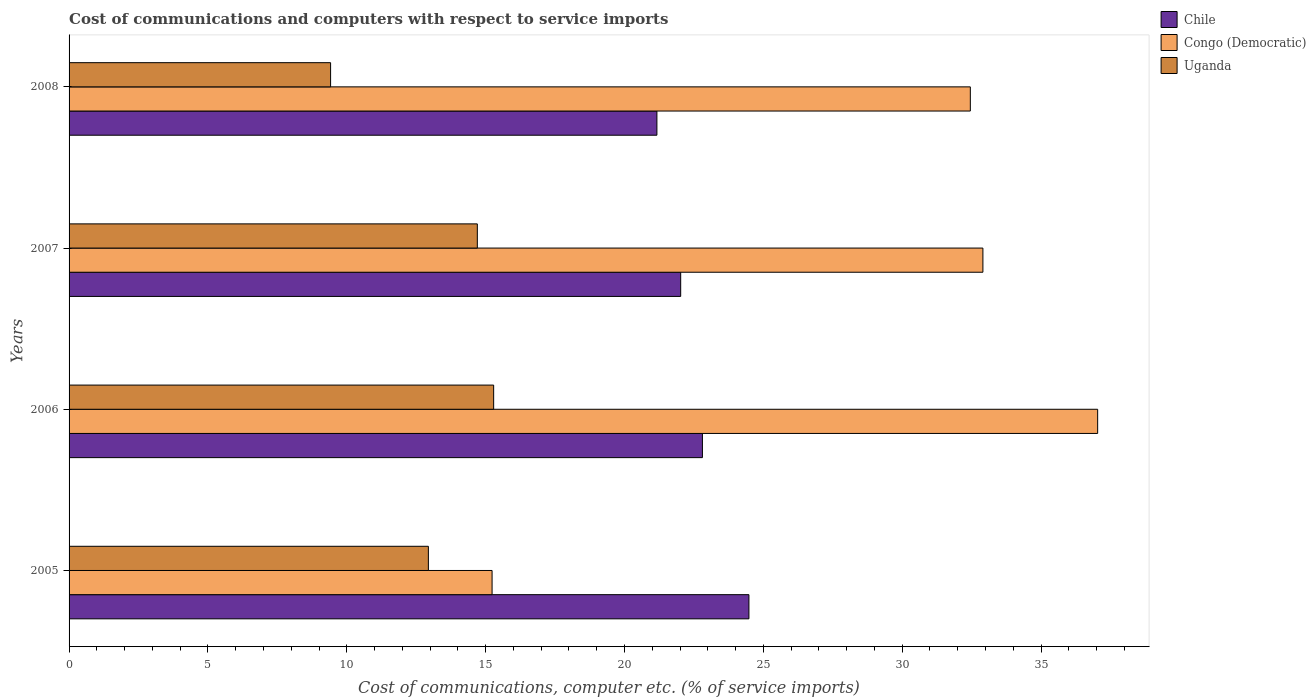How many different coloured bars are there?
Offer a very short reply. 3. How many bars are there on the 3rd tick from the top?
Offer a very short reply. 3. How many bars are there on the 4th tick from the bottom?
Offer a terse response. 3. In how many cases, is the number of bars for a given year not equal to the number of legend labels?
Give a very brief answer. 0. What is the cost of communications and computers in Uganda in 2006?
Your response must be concise. 15.29. Across all years, what is the maximum cost of communications and computers in Congo (Democratic)?
Your response must be concise. 37.04. Across all years, what is the minimum cost of communications and computers in Uganda?
Make the answer very short. 9.42. In which year was the cost of communications and computers in Chile minimum?
Make the answer very short. 2008. What is the total cost of communications and computers in Chile in the graph?
Provide a succinct answer. 90.48. What is the difference between the cost of communications and computers in Uganda in 2007 and that in 2008?
Offer a terse response. 5.28. What is the difference between the cost of communications and computers in Chile in 2006 and the cost of communications and computers in Uganda in 2005?
Provide a succinct answer. 9.87. What is the average cost of communications and computers in Chile per year?
Give a very brief answer. 22.62. In the year 2005, what is the difference between the cost of communications and computers in Chile and cost of communications and computers in Congo (Democratic)?
Offer a very short reply. 9.25. What is the ratio of the cost of communications and computers in Congo (Democratic) in 2006 to that in 2007?
Your answer should be compact. 1.13. Is the difference between the cost of communications and computers in Chile in 2005 and 2006 greater than the difference between the cost of communications and computers in Congo (Democratic) in 2005 and 2006?
Offer a very short reply. Yes. What is the difference between the highest and the second highest cost of communications and computers in Chile?
Make the answer very short. 1.67. What is the difference between the highest and the lowest cost of communications and computers in Congo (Democratic)?
Ensure brevity in your answer.  21.81. What does the 1st bar from the top in 2007 represents?
Your answer should be very brief. Uganda. What does the 2nd bar from the bottom in 2008 represents?
Offer a terse response. Congo (Democratic). Is it the case that in every year, the sum of the cost of communications and computers in Congo (Democratic) and cost of communications and computers in Uganda is greater than the cost of communications and computers in Chile?
Your answer should be very brief. Yes. How many bars are there?
Your answer should be compact. 12. Are all the bars in the graph horizontal?
Provide a short and direct response. Yes. How many years are there in the graph?
Provide a succinct answer. 4. Are the values on the major ticks of X-axis written in scientific E-notation?
Provide a short and direct response. No. Does the graph contain any zero values?
Offer a very short reply. No. Does the graph contain grids?
Provide a short and direct response. No. How many legend labels are there?
Your answer should be very brief. 3. What is the title of the graph?
Your answer should be compact. Cost of communications and computers with respect to service imports. What is the label or title of the X-axis?
Your response must be concise. Cost of communications, computer etc. (% of service imports). What is the label or title of the Y-axis?
Provide a short and direct response. Years. What is the Cost of communications, computer etc. (% of service imports) of Chile in 2005?
Offer a very short reply. 24.48. What is the Cost of communications, computer etc. (% of service imports) of Congo (Democratic) in 2005?
Offer a terse response. 15.23. What is the Cost of communications, computer etc. (% of service imports) of Uganda in 2005?
Ensure brevity in your answer.  12.94. What is the Cost of communications, computer etc. (% of service imports) in Chile in 2006?
Ensure brevity in your answer.  22.81. What is the Cost of communications, computer etc. (% of service imports) of Congo (Democratic) in 2006?
Keep it short and to the point. 37.04. What is the Cost of communications, computer etc. (% of service imports) in Uganda in 2006?
Give a very brief answer. 15.29. What is the Cost of communications, computer etc. (% of service imports) in Chile in 2007?
Make the answer very short. 22.02. What is the Cost of communications, computer etc. (% of service imports) of Congo (Democratic) in 2007?
Offer a terse response. 32.91. What is the Cost of communications, computer etc. (% of service imports) in Uganda in 2007?
Provide a short and direct response. 14.7. What is the Cost of communications, computer etc. (% of service imports) of Chile in 2008?
Your answer should be very brief. 21.17. What is the Cost of communications, computer etc. (% of service imports) of Congo (Democratic) in 2008?
Keep it short and to the point. 32.45. What is the Cost of communications, computer etc. (% of service imports) in Uganda in 2008?
Your answer should be compact. 9.42. Across all years, what is the maximum Cost of communications, computer etc. (% of service imports) of Chile?
Make the answer very short. 24.48. Across all years, what is the maximum Cost of communications, computer etc. (% of service imports) in Congo (Democratic)?
Make the answer very short. 37.04. Across all years, what is the maximum Cost of communications, computer etc. (% of service imports) of Uganda?
Your answer should be compact. 15.29. Across all years, what is the minimum Cost of communications, computer etc. (% of service imports) in Chile?
Give a very brief answer. 21.17. Across all years, what is the minimum Cost of communications, computer etc. (% of service imports) of Congo (Democratic)?
Keep it short and to the point. 15.23. Across all years, what is the minimum Cost of communications, computer etc. (% of service imports) in Uganda?
Ensure brevity in your answer.  9.42. What is the total Cost of communications, computer etc. (% of service imports) in Chile in the graph?
Provide a short and direct response. 90.48. What is the total Cost of communications, computer etc. (% of service imports) in Congo (Democratic) in the graph?
Offer a terse response. 117.63. What is the total Cost of communications, computer etc. (% of service imports) in Uganda in the graph?
Keep it short and to the point. 52.35. What is the difference between the Cost of communications, computer etc. (% of service imports) of Chile in 2005 and that in 2006?
Make the answer very short. 1.67. What is the difference between the Cost of communications, computer etc. (% of service imports) in Congo (Democratic) in 2005 and that in 2006?
Keep it short and to the point. -21.81. What is the difference between the Cost of communications, computer etc. (% of service imports) in Uganda in 2005 and that in 2006?
Your answer should be compact. -2.35. What is the difference between the Cost of communications, computer etc. (% of service imports) in Chile in 2005 and that in 2007?
Provide a succinct answer. 2.46. What is the difference between the Cost of communications, computer etc. (% of service imports) in Congo (Democratic) in 2005 and that in 2007?
Your answer should be very brief. -17.67. What is the difference between the Cost of communications, computer etc. (% of service imports) in Uganda in 2005 and that in 2007?
Offer a terse response. -1.76. What is the difference between the Cost of communications, computer etc. (% of service imports) of Chile in 2005 and that in 2008?
Your answer should be compact. 3.31. What is the difference between the Cost of communications, computer etc. (% of service imports) in Congo (Democratic) in 2005 and that in 2008?
Give a very brief answer. -17.22. What is the difference between the Cost of communications, computer etc. (% of service imports) of Uganda in 2005 and that in 2008?
Your answer should be compact. 3.52. What is the difference between the Cost of communications, computer etc. (% of service imports) in Chile in 2006 and that in 2007?
Ensure brevity in your answer.  0.78. What is the difference between the Cost of communications, computer etc. (% of service imports) in Congo (Democratic) in 2006 and that in 2007?
Offer a terse response. 4.13. What is the difference between the Cost of communications, computer etc. (% of service imports) of Uganda in 2006 and that in 2007?
Offer a very short reply. 0.59. What is the difference between the Cost of communications, computer etc. (% of service imports) in Chile in 2006 and that in 2008?
Provide a succinct answer. 1.64. What is the difference between the Cost of communications, computer etc. (% of service imports) in Congo (Democratic) in 2006 and that in 2008?
Provide a short and direct response. 4.59. What is the difference between the Cost of communications, computer etc. (% of service imports) in Uganda in 2006 and that in 2008?
Provide a short and direct response. 5.87. What is the difference between the Cost of communications, computer etc. (% of service imports) of Chile in 2007 and that in 2008?
Offer a very short reply. 0.86. What is the difference between the Cost of communications, computer etc. (% of service imports) in Congo (Democratic) in 2007 and that in 2008?
Provide a succinct answer. 0.45. What is the difference between the Cost of communications, computer etc. (% of service imports) in Uganda in 2007 and that in 2008?
Give a very brief answer. 5.28. What is the difference between the Cost of communications, computer etc. (% of service imports) of Chile in 2005 and the Cost of communications, computer etc. (% of service imports) of Congo (Democratic) in 2006?
Your answer should be very brief. -12.56. What is the difference between the Cost of communications, computer etc. (% of service imports) in Chile in 2005 and the Cost of communications, computer etc. (% of service imports) in Uganda in 2006?
Offer a very short reply. 9.19. What is the difference between the Cost of communications, computer etc. (% of service imports) in Congo (Democratic) in 2005 and the Cost of communications, computer etc. (% of service imports) in Uganda in 2006?
Offer a terse response. -0.06. What is the difference between the Cost of communications, computer etc. (% of service imports) of Chile in 2005 and the Cost of communications, computer etc. (% of service imports) of Congo (Democratic) in 2007?
Provide a short and direct response. -8.43. What is the difference between the Cost of communications, computer etc. (% of service imports) in Chile in 2005 and the Cost of communications, computer etc. (% of service imports) in Uganda in 2007?
Offer a terse response. 9.78. What is the difference between the Cost of communications, computer etc. (% of service imports) in Congo (Democratic) in 2005 and the Cost of communications, computer etc. (% of service imports) in Uganda in 2007?
Give a very brief answer. 0.53. What is the difference between the Cost of communications, computer etc. (% of service imports) of Chile in 2005 and the Cost of communications, computer etc. (% of service imports) of Congo (Democratic) in 2008?
Your answer should be compact. -7.97. What is the difference between the Cost of communications, computer etc. (% of service imports) in Chile in 2005 and the Cost of communications, computer etc. (% of service imports) in Uganda in 2008?
Provide a short and direct response. 15.06. What is the difference between the Cost of communications, computer etc. (% of service imports) in Congo (Democratic) in 2005 and the Cost of communications, computer etc. (% of service imports) in Uganda in 2008?
Ensure brevity in your answer.  5.82. What is the difference between the Cost of communications, computer etc. (% of service imports) of Chile in 2006 and the Cost of communications, computer etc. (% of service imports) of Congo (Democratic) in 2007?
Make the answer very short. -10.1. What is the difference between the Cost of communications, computer etc. (% of service imports) of Chile in 2006 and the Cost of communications, computer etc. (% of service imports) of Uganda in 2007?
Provide a succinct answer. 8.11. What is the difference between the Cost of communications, computer etc. (% of service imports) of Congo (Democratic) in 2006 and the Cost of communications, computer etc. (% of service imports) of Uganda in 2007?
Make the answer very short. 22.34. What is the difference between the Cost of communications, computer etc. (% of service imports) in Chile in 2006 and the Cost of communications, computer etc. (% of service imports) in Congo (Democratic) in 2008?
Your answer should be compact. -9.65. What is the difference between the Cost of communications, computer etc. (% of service imports) in Chile in 2006 and the Cost of communications, computer etc. (% of service imports) in Uganda in 2008?
Your answer should be very brief. 13.39. What is the difference between the Cost of communications, computer etc. (% of service imports) in Congo (Democratic) in 2006 and the Cost of communications, computer etc. (% of service imports) in Uganda in 2008?
Your response must be concise. 27.62. What is the difference between the Cost of communications, computer etc. (% of service imports) in Chile in 2007 and the Cost of communications, computer etc. (% of service imports) in Congo (Democratic) in 2008?
Offer a terse response. -10.43. What is the difference between the Cost of communications, computer etc. (% of service imports) in Chile in 2007 and the Cost of communications, computer etc. (% of service imports) in Uganda in 2008?
Offer a very short reply. 12.61. What is the difference between the Cost of communications, computer etc. (% of service imports) in Congo (Democratic) in 2007 and the Cost of communications, computer etc. (% of service imports) in Uganda in 2008?
Give a very brief answer. 23.49. What is the average Cost of communications, computer etc. (% of service imports) in Chile per year?
Provide a short and direct response. 22.62. What is the average Cost of communications, computer etc. (% of service imports) in Congo (Democratic) per year?
Your answer should be very brief. 29.41. What is the average Cost of communications, computer etc. (% of service imports) in Uganda per year?
Give a very brief answer. 13.09. In the year 2005, what is the difference between the Cost of communications, computer etc. (% of service imports) in Chile and Cost of communications, computer etc. (% of service imports) in Congo (Democratic)?
Ensure brevity in your answer.  9.25. In the year 2005, what is the difference between the Cost of communications, computer etc. (% of service imports) of Chile and Cost of communications, computer etc. (% of service imports) of Uganda?
Keep it short and to the point. 11.54. In the year 2005, what is the difference between the Cost of communications, computer etc. (% of service imports) in Congo (Democratic) and Cost of communications, computer etc. (% of service imports) in Uganda?
Your response must be concise. 2.29. In the year 2006, what is the difference between the Cost of communications, computer etc. (% of service imports) in Chile and Cost of communications, computer etc. (% of service imports) in Congo (Democratic)?
Your answer should be very brief. -14.23. In the year 2006, what is the difference between the Cost of communications, computer etc. (% of service imports) in Chile and Cost of communications, computer etc. (% of service imports) in Uganda?
Give a very brief answer. 7.52. In the year 2006, what is the difference between the Cost of communications, computer etc. (% of service imports) in Congo (Democratic) and Cost of communications, computer etc. (% of service imports) in Uganda?
Offer a terse response. 21.75. In the year 2007, what is the difference between the Cost of communications, computer etc. (% of service imports) of Chile and Cost of communications, computer etc. (% of service imports) of Congo (Democratic)?
Your answer should be compact. -10.88. In the year 2007, what is the difference between the Cost of communications, computer etc. (% of service imports) in Chile and Cost of communications, computer etc. (% of service imports) in Uganda?
Ensure brevity in your answer.  7.32. In the year 2007, what is the difference between the Cost of communications, computer etc. (% of service imports) in Congo (Democratic) and Cost of communications, computer etc. (% of service imports) in Uganda?
Your response must be concise. 18.21. In the year 2008, what is the difference between the Cost of communications, computer etc. (% of service imports) of Chile and Cost of communications, computer etc. (% of service imports) of Congo (Democratic)?
Offer a very short reply. -11.29. In the year 2008, what is the difference between the Cost of communications, computer etc. (% of service imports) of Chile and Cost of communications, computer etc. (% of service imports) of Uganda?
Your answer should be compact. 11.75. In the year 2008, what is the difference between the Cost of communications, computer etc. (% of service imports) in Congo (Democratic) and Cost of communications, computer etc. (% of service imports) in Uganda?
Your response must be concise. 23.04. What is the ratio of the Cost of communications, computer etc. (% of service imports) of Chile in 2005 to that in 2006?
Offer a terse response. 1.07. What is the ratio of the Cost of communications, computer etc. (% of service imports) of Congo (Democratic) in 2005 to that in 2006?
Make the answer very short. 0.41. What is the ratio of the Cost of communications, computer etc. (% of service imports) of Uganda in 2005 to that in 2006?
Give a very brief answer. 0.85. What is the ratio of the Cost of communications, computer etc. (% of service imports) of Chile in 2005 to that in 2007?
Give a very brief answer. 1.11. What is the ratio of the Cost of communications, computer etc. (% of service imports) in Congo (Democratic) in 2005 to that in 2007?
Give a very brief answer. 0.46. What is the ratio of the Cost of communications, computer etc. (% of service imports) of Uganda in 2005 to that in 2007?
Make the answer very short. 0.88. What is the ratio of the Cost of communications, computer etc. (% of service imports) of Chile in 2005 to that in 2008?
Give a very brief answer. 1.16. What is the ratio of the Cost of communications, computer etc. (% of service imports) of Congo (Democratic) in 2005 to that in 2008?
Ensure brevity in your answer.  0.47. What is the ratio of the Cost of communications, computer etc. (% of service imports) of Uganda in 2005 to that in 2008?
Keep it short and to the point. 1.37. What is the ratio of the Cost of communications, computer etc. (% of service imports) in Chile in 2006 to that in 2007?
Offer a terse response. 1.04. What is the ratio of the Cost of communications, computer etc. (% of service imports) of Congo (Democratic) in 2006 to that in 2007?
Your answer should be very brief. 1.13. What is the ratio of the Cost of communications, computer etc. (% of service imports) of Chile in 2006 to that in 2008?
Provide a succinct answer. 1.08. What is the ratio of the Cost of communications, computer etc. (% of service imports) in Congo (Democratic) in 2006 to that in 2008?
Make the answer very short. 1.14. What is the ratio of the Cost of communications, computer etc. (% of service imports) in Uganda in 2006 to that in 2008?
Ensure brevity in your answer.  1.62. What is the ratio of the Cost of communications, computer etc. (% of service imports) of Chile in 2007 to that in 2008?
Offer a very short reply. 1.04. What is the ratio of the Cost of communications, computer etc. (% of service imports) of Uganda in 2007 to that in 2008?
Your answer should be compact. 1.56. What is the difference between the highest and the second highest Cost of communications, computer etc. (% of service imports) in Chile?
Your answer should be very brief. 1.67. What is the difference between the highest and the second highest Cost of communications, computer etc. (% of service imports) in Congo (Democratic)?
Offer a terse response. 4.13. What is the difference between the highest and the second highest Cost of communications, computer etc. (% of service imports) of Uganda?
Give a very brief answer. 0.59. What is the difference between the highest and the lowest Cost of communications, computer etc. (% of service imports) of Chile?
Provide a short and direct response. 3.31. What is the difference between the highest and the lowest Cost of communications, computer etc. (% of service imports) in Congo (Democratic)?
Offer a terse response. 21.81. What is the difference between the highest and the lowest Cost of communications, computer etc. (% of service imports) of Uganda?
Make the answer very short. 5.87. 